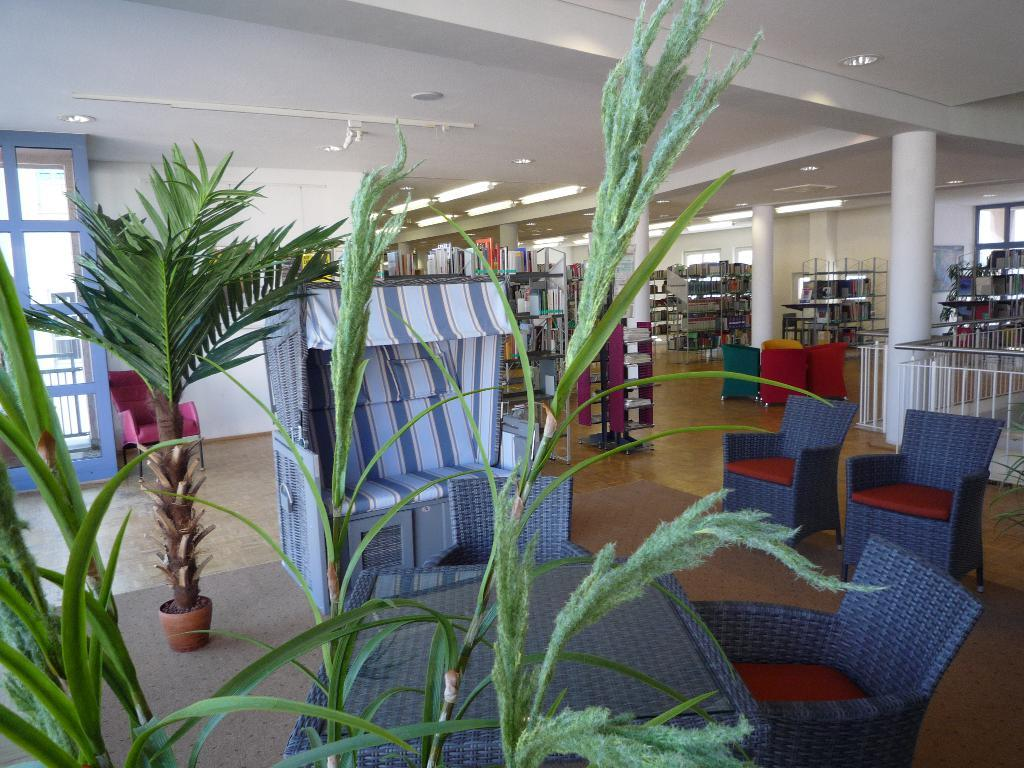What type of vegetation is on the left side of the image? There are plants on the left side of the image. What type of furniture is in the middle of the image? There are sofa chairs in the middle of the image. What type of location does the image appear to depict? The setting appears to be a library. What type of items can be seen on the racks in the image? There are books in the racks at the back side of the image. Where is the gate located in the image? There is no gate present in the image. Can you see any bats flying around in the image? There are no bats visible in the image. 